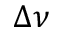Convert formula to latex. <formula><loc_0><loc_0><loc_500><loc_500>\Delta \nu</formula> 